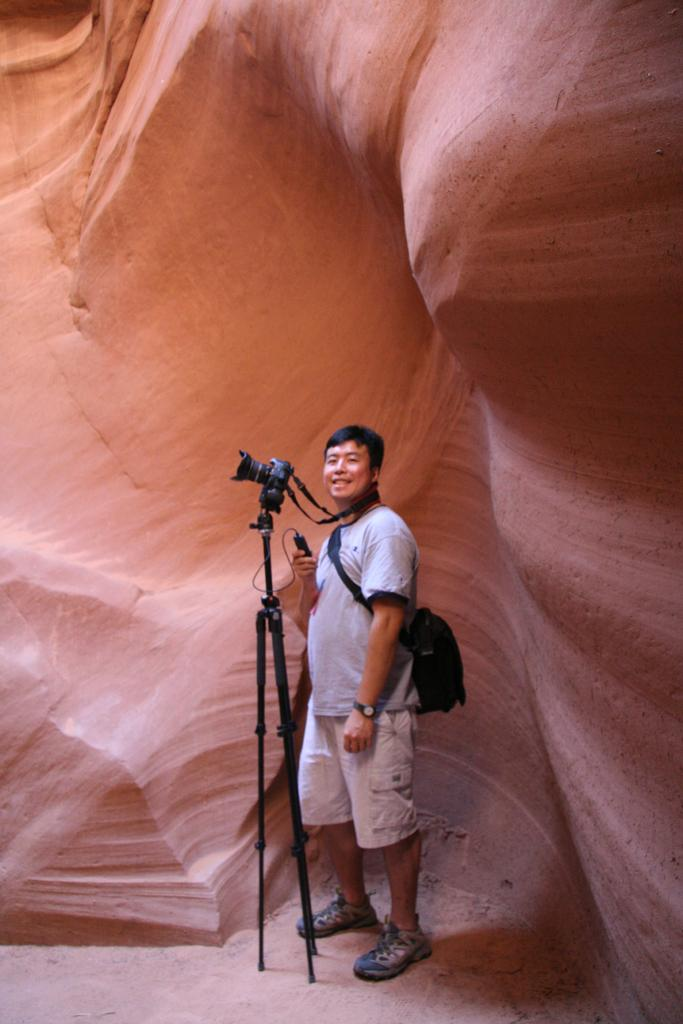What is the main subject of the image? There is a person in the image. What is the person holding in the image? The person is holding an object. Can you describe the person's clothing in the image? The person is wearing stripes. What else is the person carrying in the image? The person is carrying a bag. What equipment can be seen in the image? There is a camera and a tripod in the image. What can be seen in the background of the image? There is a canyon in the background of the image. What type of print can be seen on the trucks in the image? There are no trucks present in the image, so there is no print to observe. 